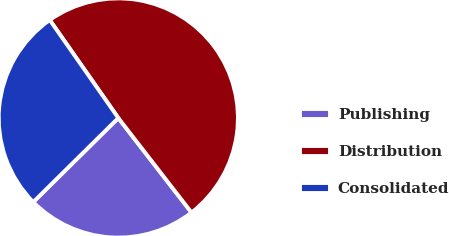<chart> <loc_0><loc_0><loc_500><loc_500><pie_chart><fcel>Publishing<fcel>Distribution<fcel>Consolidated<nl><fcel>23.08%<fcel>49.23%<fcel>27.69%<nl></chart> 